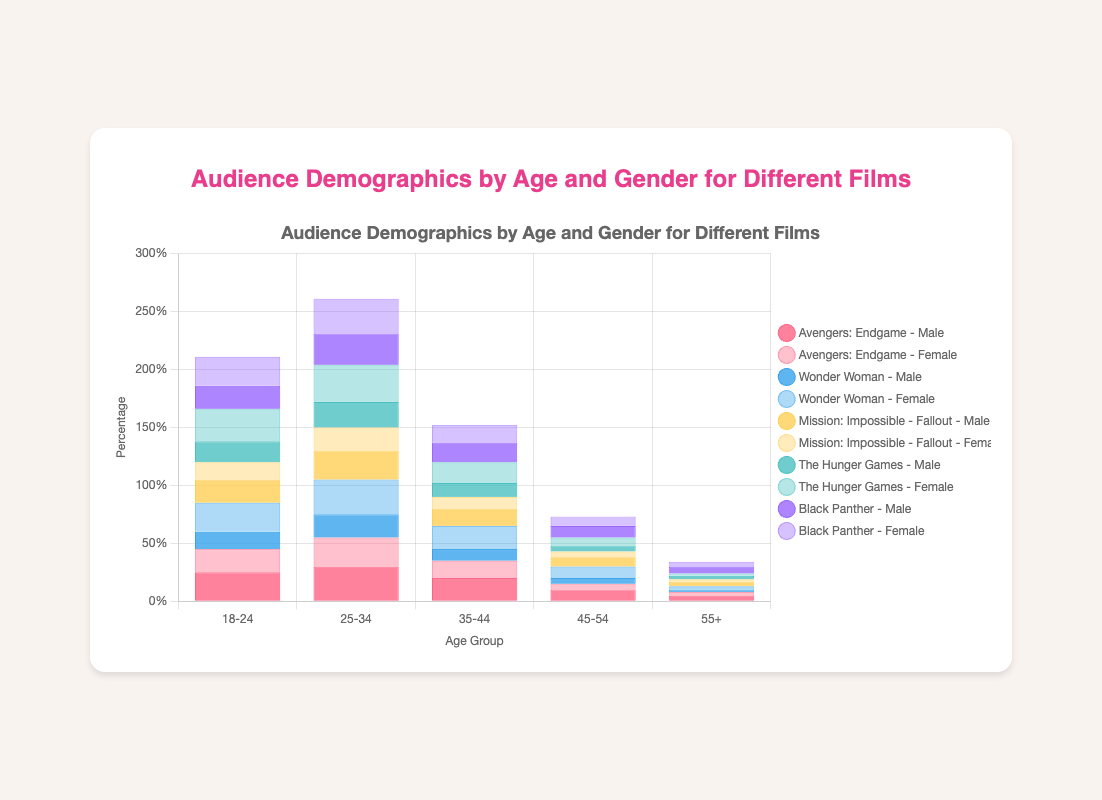Which film has the largest audience in the 25-34 age group? Identify the heights of the stacked bars for the 25-34 age group. Sum the values for both males and females. The film with the highest total is the answer. "Avengers: Endgame" has 55, "Wonder Woman" has 50, "Mission: Impossible - Fallout" has 45, "The Hunger Games" has 54, and "Black Panther" has 57.
Answer: Black Panther Which age group has the smallest male audience for "Wonder Woman"? Identify the bars corresponding to males in each age group for "Wonder Woman." Compare the heights to determine the smallest value. The values for males are: 18-24 (15), 25-34 (20), 35-44 (10), 45-54 (5), and 55+ (2).
Answer: 55+ Is there any age group where "The Hunger Games" has more females than "Black Panther"? Compare the heights of the female audience for each age group between "The Hunger Games" and "Black Panther." Check if there is at least one age group where the female audience of "The Hunger Games" is higher than "Black Panther." In the 18-24 age group, "The Hunger Games" has a female audience of 28 and "Black Panther" has 25.
Answer: Yes What is the combined audience for males in the 18-24 age group for all films? Sum the male audience values for the 18-24 age group across all films. Values are: "Avengers: Endgame" (25), "Wonder Woman" (15), "Mission: Impossible - Fallout" (20), "The Hunger Games" (18), and "Black Panther" (20). Sum: 25 + 15 + 20 + 18 + 20 = 98.
Answer: 98 Which film has a greater gender difference in the 35-44 age group? Calculate the absolute difference between male and female audiences in the 35-44 age group for each film. Differences are: "Avengers: Endgame" (20 - 15 = 5), "Wonder Woman" (20 - 10 = 10), "Mission: Impossible - Fallout" (15 - 10 = 5), "The Hunger Games" (18 - 12 = 6), and "Black Panther" (17 - 15 = 2). The greatest difference is for "Wonder Woman."
Answer: Wonder Woman In which film, the female age group 25-34 exceeds the male audience by the greatest margin? Calculate the difference between female and male audiences for the 25-34 age group. The differences are: "Avengers: Endgame" (25 - 30 = -5), "Wonder Woman" (30 - 20 = 10), "Mission: Impossible - Fallout" (20 - 25 = -5), "The Hunger Games" (32 - 22 = 10), and "Black Panther" (30 - 27 = 3).
Answer: Wonder Woman and The Hunger Games Which age group in "Avengers: Endgame" has the closest male and female audience ratio? Calculate the ratio of male to female audiences in each age group for "Avengers: Endgame." The ratios are: 18-24 (25/20 = 1.25), 25-34 (30/25 = 1.2), 35-44 (20/15 = 1.33), 45-54 (10/5 = 2), and 55+ (5/3 = 1.67). The closest ratio to 1 is 25-34 (1.2).
Answer: 25-34 If you combine the 18-24 and 25-34 male audiences for "Mission: Impossible - Fallout," is it more than the total female audience in the same age groups for "Black Panther"? First, add the male audiences for 18-24 and 25-34 in "Mission: Impossible - Fallout" (20 + 25 = 45). Then, add the female audiences for the same age groups in "Black Panther" (25 + 30 = 55). Compare: 45 < 55.
Answer: No 